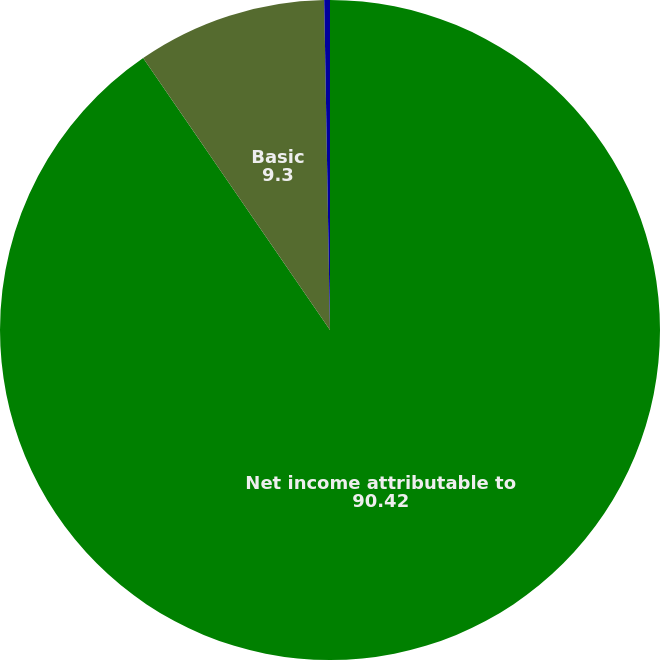Convert chart. <chart><loc_0><loc_0><loc_500><loc_500><pie_chart><fcel>Net income attributable to<fcel>Basic<fcel>Diluted<nl><fcel>90.42%<fcel>9.3%<fcel>0.28%<nl></chart> 